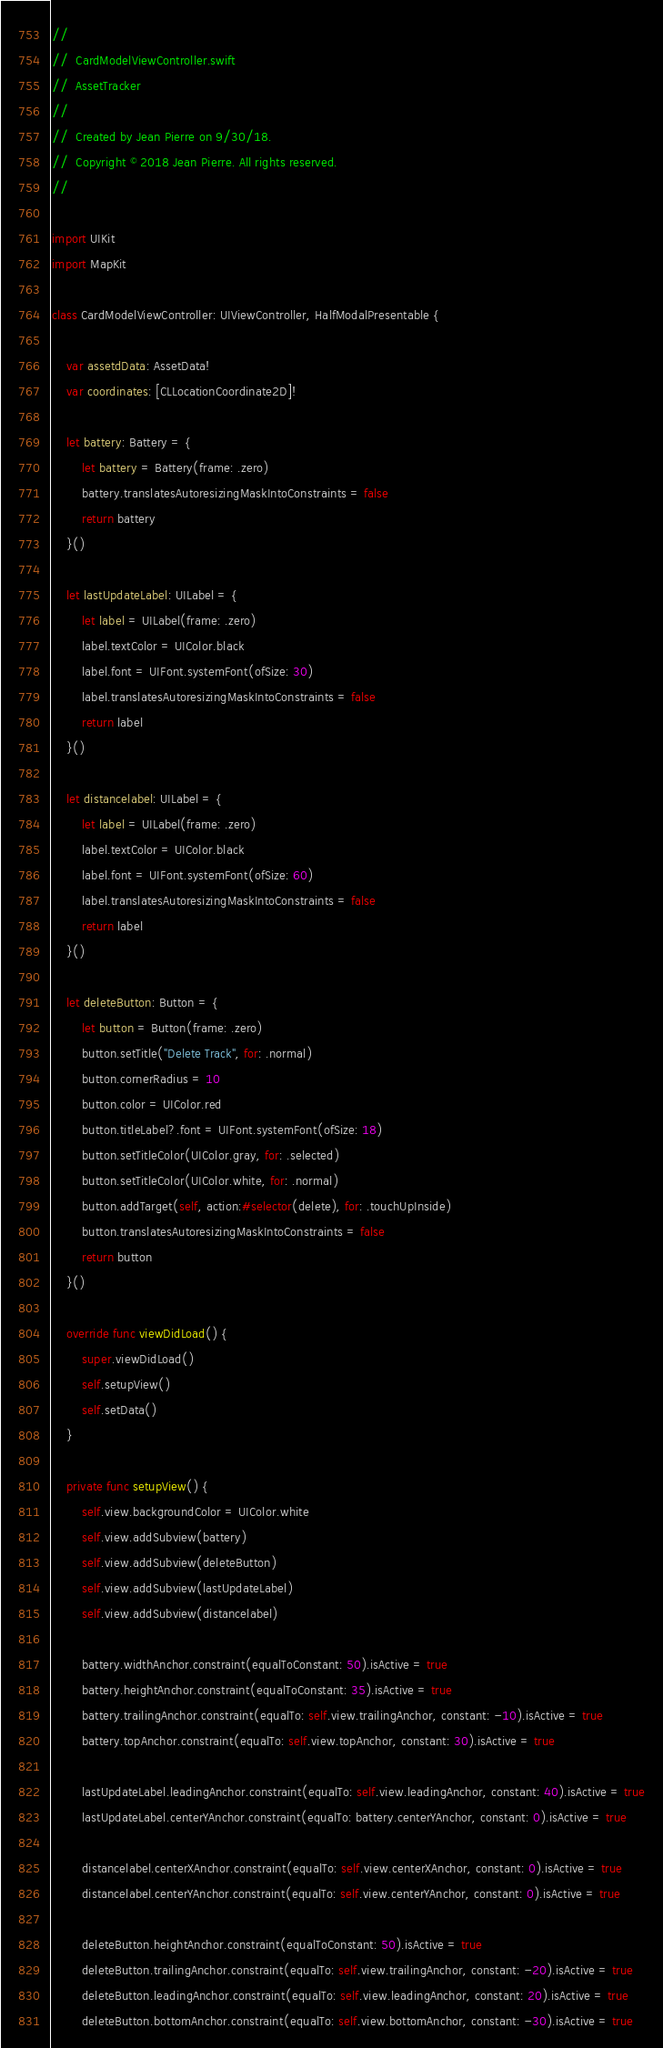Convert code to text. <code><loc_0><loc_0><loc_500><loc_500><_Swift_>//
//  CardModelViewController.swift
//  AssetTracker
//
//  Created by Jean Pierre on 9/30/18.
//  Copyright © 2018 Jean Pierre. All rights reserved.
//

import UIKit
import MapKit

class CardModelViewController: UIViewController, HalfModalPresentable {
    
    var assetdData: AssetData!
    var coordinates: [CLLocationCoordinate2D]!
    
    let battery: Battery = {
        let battery = Battery(frame: .zero)
        battery.translatesAutoresizingMaskIntoConstraints = false
        return battery
    }()
    
    let lastUpdateLabel: UILabel = {
        let label = UILabel(frame: .zero)
        label.textColor = UIColor.black
        label.font = UIFont.systemFont(ofSize: 30)
        label.translatesAutoresizingMaskIntoConstraints = false
        return label
    }()
    
    let distancelabel: UILabel = {
        let label = UILabel(frame: .zero)
        label.textColor = UIColor.black
        label.font = UIFont.systemFont(ofSize: 60)
        label.translatesAutoresizingMaskIntoConstraints = false
        return label
    }()
    
    let deleteButton: Button = {
        let button = Button(frame: .zero)
        button.setTitle("Delete Track", for: .normal)
        button.cornerRadius = 10
        button.color = UIColor.red
        button.titleLabel?.font = UIFont.systemFont(ofSize: 18)
        button.setTitleColor(UIColor.gray, for: .selected)
        button.setTitleColor(UIColor.white, for: .normal)
        button.addTarget(self, action:#selector(delete), for: .touchUpInside)
        button.translatesAutoresizingMaskIntoConstraints = false
        return button
    }()

    override func viewDidLoad() {
        super.viewDidLoad()
        self.setupView()
        self.setData()
    }
    
    private func setupView() {
        self.view.backgroundColor = UIColor.white
        self.view.addSubview(battery)
        self.view.addSubview(deleteButton)
        self.view.addSubview(lastUpdateLabel)
        self.view.addSubview(distancelabel)
    
        battery.widthAnchor.constraint(equalToConstant: 50).isActive = true
        battery.heightAnchor.constraint(equalToConstant: 35).isActive = true
        battery.trailingAnchor.constraint(equalTo: self.view.trailingAnchor, constant: -10).isActive = true
        battery.topAnchor.constraint(equalTo: self.view.topAnchor, constant: 30).isActive = true
        
        lastUpdateLabel.leadingAnchor.constraint(equalTo: self.view.leadingAnchor, constant: 40).isActive = true
        lastUpdateLabel.centerYAnchor.constraint(equalTo: battery.centerYAnchor, constant: 0).isActive = true
        
        distancelabel.centerXAnchor.constraint(equalTo: self.view.centerXAnchor, constant: 0).isActive = true
        distancelabel.centerYAnchor.constraint(equalTo: self.view.centerYAnchor, constant: 0).isActive = true
        
        deleteButton.heightAnchor.constraint(equalToConstant: 50).isActive = true
        deleteButton.trailingAnchor.constraint(equalTo: self.view.trailingAnchor, constant: -20).isActive = true
        deleteButton.leadingAnchor.constraint(equalTo: self.view.leadingAnchor, constant: 20).isActive = true
        deleteButton.bottomAnchor.constraint(equalTo: self.view.bottomAnchor, constant: -30).isActive = true</code> 